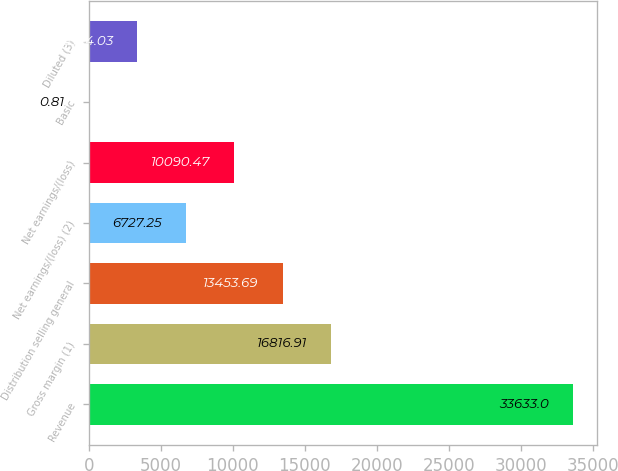<chart> <loc_0><loc_0><loc_500><loc_500><bar_chart><fcel>Revenue<fcel>Gross margin (1)<fcel>Distribution selling general<fcel>Net earnings/(loss) (2)<fcel>Net earnings/(loss)<fcel>Basic<fcel>Diluted (3)<nl><fcel>33633<fcel>16816.9<fcel>13453.7<fcel>6727.25<fcel>10090.5<fcel>0.81<fcel>3364.03<nl></chart> 